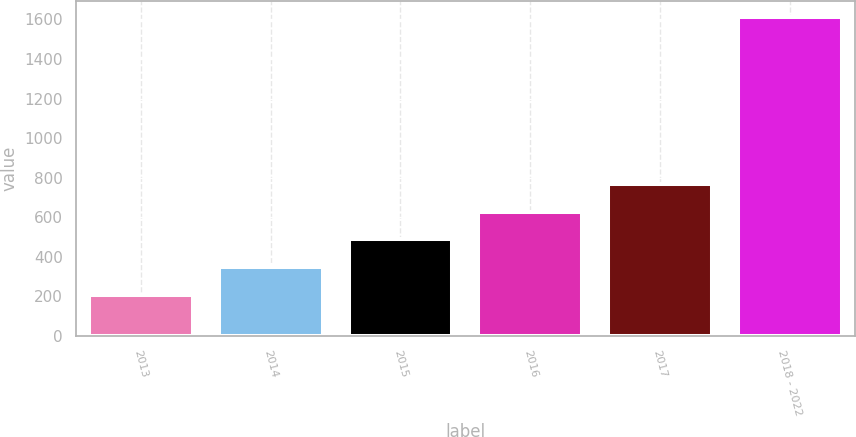<chart> <loc_0><loc_0><loc_500><loc_500><bar_chart><fcel>2013<fcel>2014<fcel>2015<fcel>2016<fcel>2017<fcel>2018 - 2022<nl><fcel>207<fcel>347.7<fcel>488.4<fcel>629.1<fcel>769.8<fcel>1614<nl></chart> 